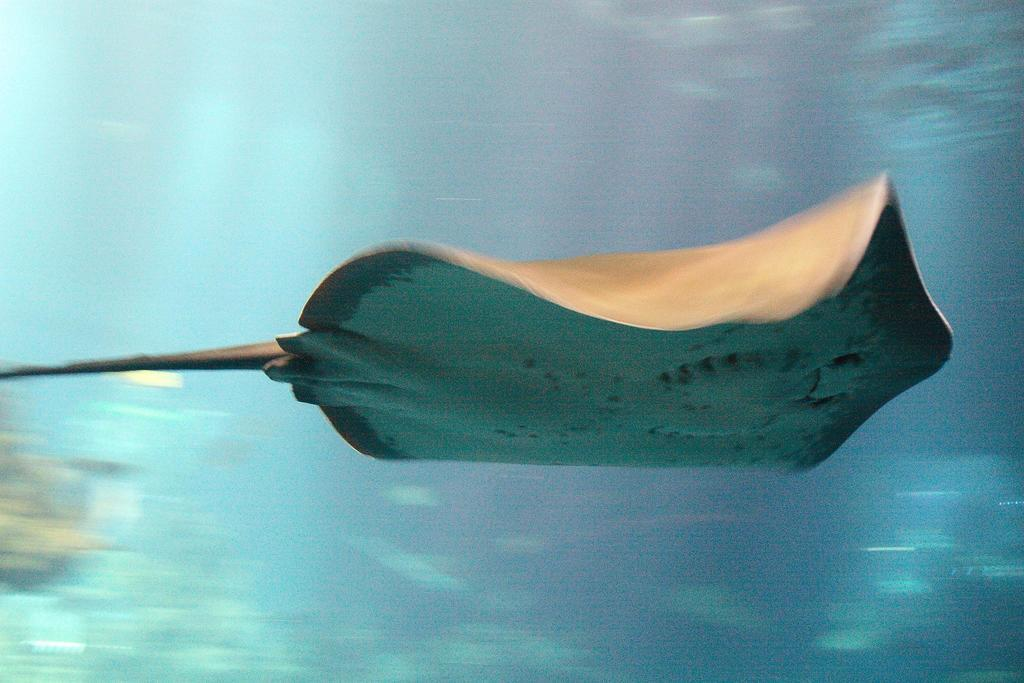What type of animal is in the image? There is a stingray in the image. Where is the stingray located? The stingray is underwater. Can you describe the background of the image? The background of the image is blurry. What type of plastic is covering the stingray's face in the image? There is no plastic covering the stingray's face in the image, as it is underwater and not wearing any mask or covering. 